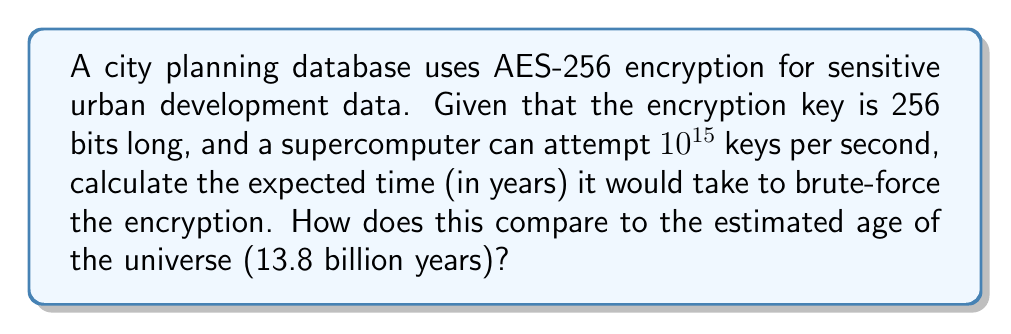Can you answer this question? Let's approach this step-by-step:

1) The number of possible keys in AES-256 is $2^{256}$, as each bit can be either 0 or 1.

2) On average, a brute-force attack would need to try half of all possible keys before finding the correct one. So, the expected number of attempts is:

   $$\frac{2^{256}}{2} = 2^{255}$$

3) The supercomputer can attempt $10^{15}$ keys per second. To find the time in seconds, we divide the number of attempts by the speed:

   $$\text{Time (in seconds)} = \frac{2^{255}}{10^{15}}$$

4) To convert this to years, we divide by the number of seconds in a year (approximately 31,536,000):

   $$\text{Time (in years)} = \frac{2^{255}}{10^{15} \times 31,536,000}$$

5) Calculating this:
   
   $$\text{Time (in years)} \approx 3.67 \times 10^{62}$$

6) Comparing to the age of the universe (13.8 billion years):

   $$\frac{3.67 \times 10^{62}}{13.8 \times 10^9} \approx 2.66 \times 10^{52}$$

This means the brute-force time is approximately $2.66 \times 10^{52}$ times longer than the current age of the universe.
Answer: $3.67 \times 10^{62}$ years, $2.66 \times 10^{52}$ times the age of the universe 